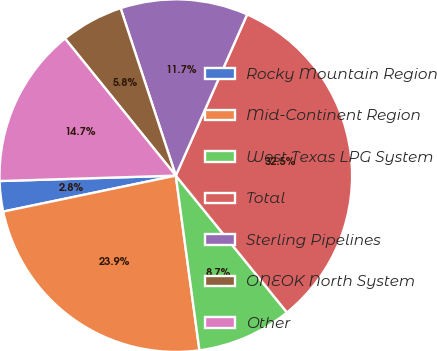<chart> <loc_0><loc_0><loc_500><loc_500><pie_chart><fcel>Rocky Mountain Region<fcel>Mid-Continent Region<fcel>West Texas LPG System<fcel>Total<fcel>Sterling Pipelines<fcel>ONEOK North System<fcel>Other<nl><fcel>2.78%<fcel>23.87%<fcel>8.72%<fcel>32.51%<fcel>11.7%<fcel>5.75%<fcel>14.67%<nl></chart> 